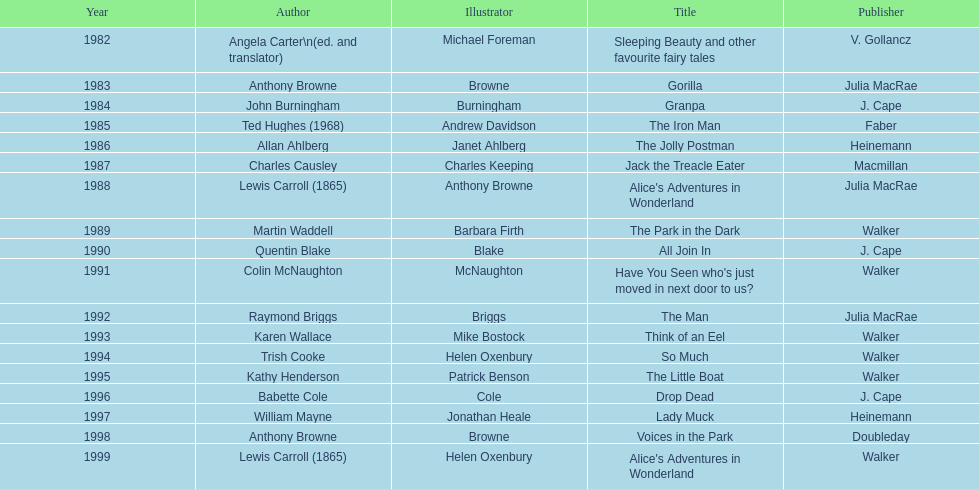Which other author, besides lewis carroll, has won the kurt maschler award twice? Anthony Browne. 